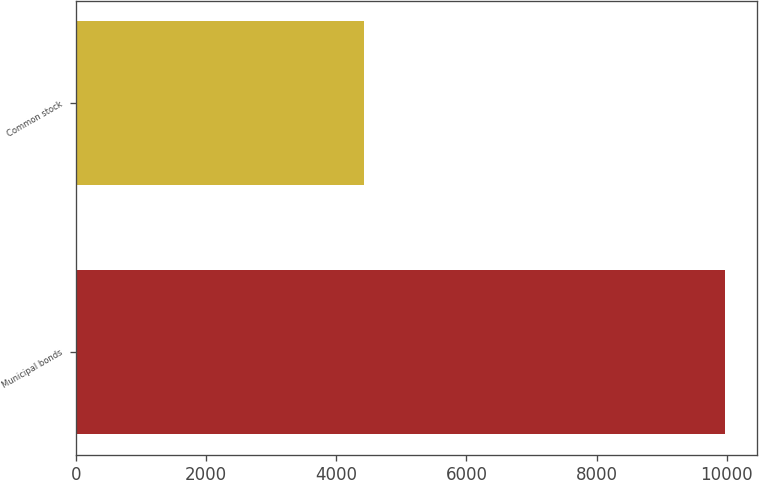Convert chart to OTSL. <chart><loc_0><loc_0><loc_500><loc_500><bar_chart><fcel>Municipal bonds<fcel>Common stock<nl><fcel>9968<fcel>4429<nl></chart> 